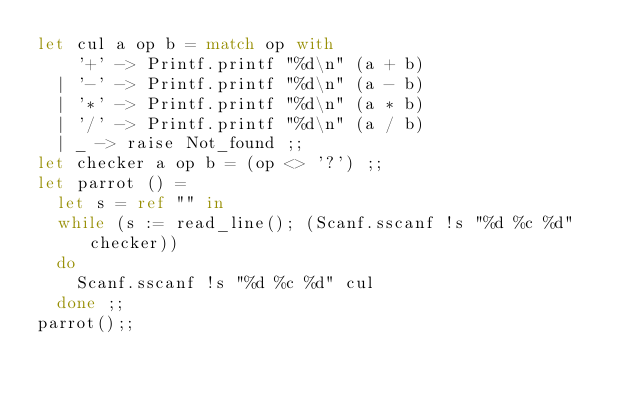<code> <loc_0><loc_0><loc_500><loc_500><_OCaml_>let cul a op b = match op with
    '+' -> Printf.printf "%d\n" (a + b)
  | '-' -> Printf.printf "%d\n" (a - b)
  | '*' -> Printf.printf "%d\n" (a * b)
  | '/' -> Printf.printf "%d\n" (a / b)
  | _ -> raise Not_found ;;
let checker a op b = (op <> '?') ;;
let parrot () =
  let s = ref "" in
  while (s := read_line(); (Scanf.sscanf !s "%d %c %d" checker))
  do
    Scanf.sscanf !s "%d %c %d" cul
  done ;;
parrot();;
</code> 